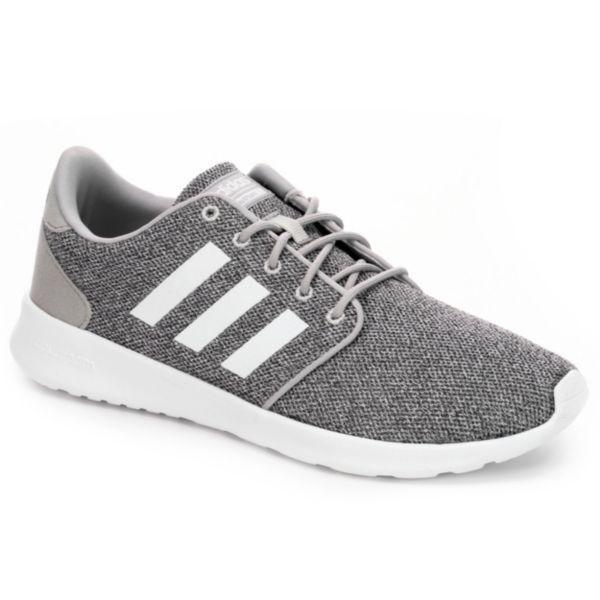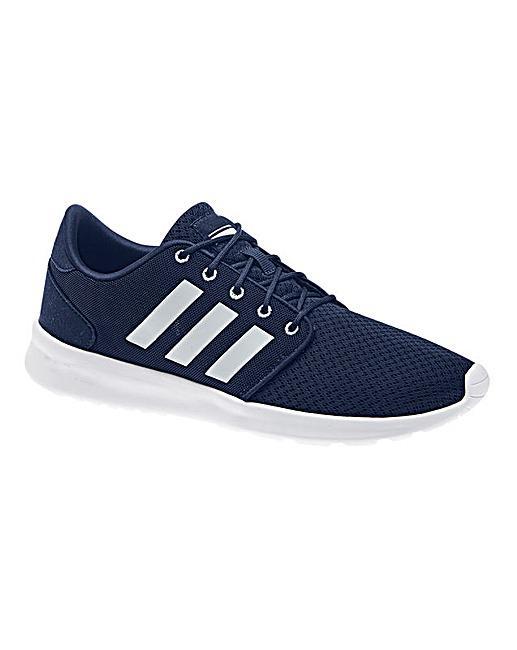The first image is the image on the left, the second image is the image on the right. Evaluate the accuracy of this statement regarding the images: "Both shoes have three white stripes on the side of them.". Is it true? Answer yes or no. Yes. The first image is the image on the left, the second image is the image on the right. Evaluate the accuracy of this statement regarding the images: "One shoe has stripes on the side that are white, and the other one has stripes on the side that are a darker color.". Is it true? Answer yes or no. No. 